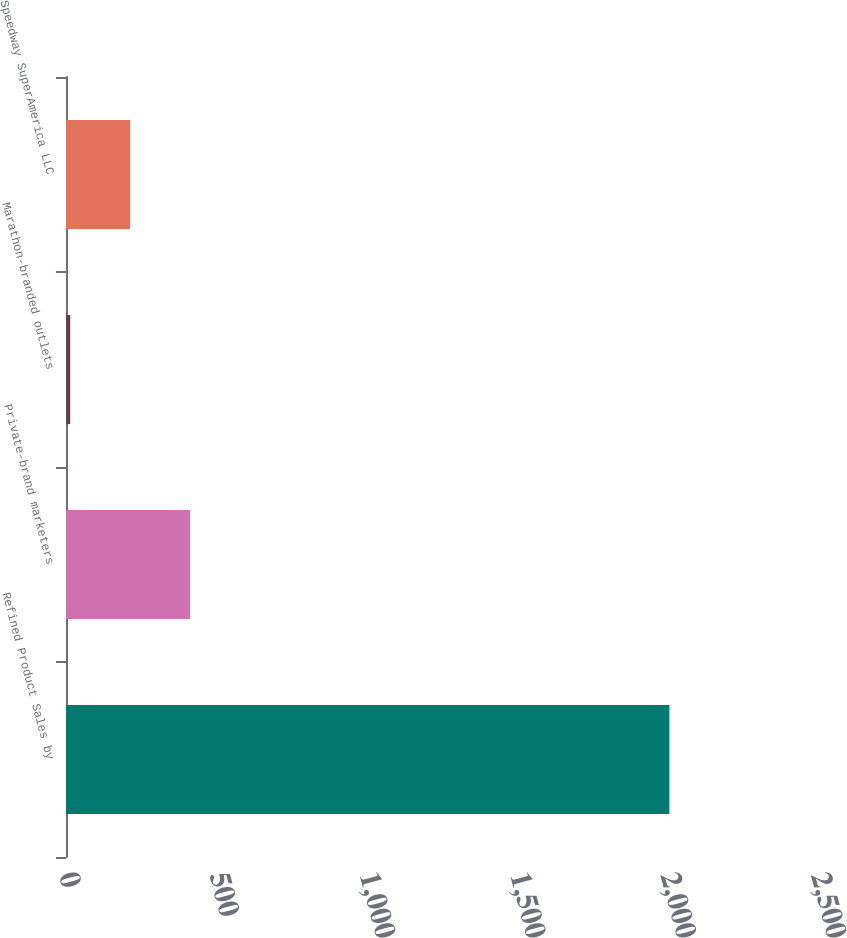Convert chart. <chart><loc_0><loc_0><loc_500><loc_500><bar_chart><fcel>Refined Product Sales by<fcel>Private-brand marketers<fcel>Marathon-branded outlets<fcel>Speedway SuperAmerica LLC<nl><fcel>2006<fcel>412.4<fcel>14<fcel>213.2<nl></chart> 